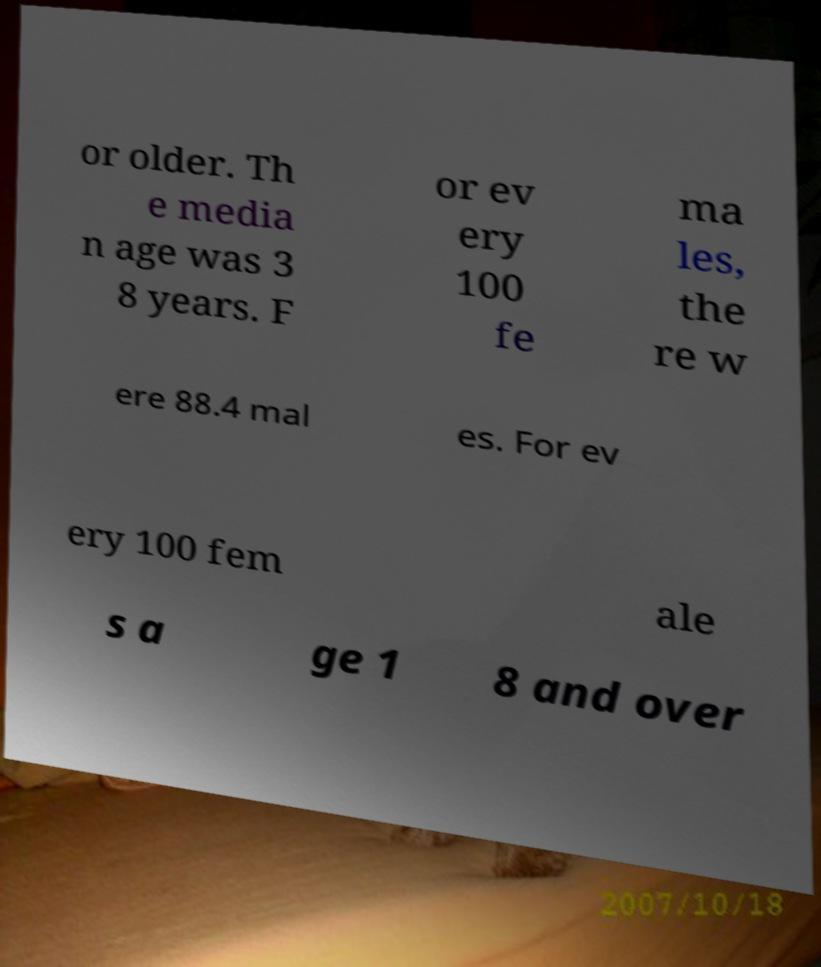Can you read and provide the text displayed in the image?This photo seems to have some interesting text. Can you extract and type it out for me? or older. Th e media n age was 3 8 years. F or ev ery 100 fe ma les, the re w ere 88.4 mal es. For ev ery 100 fem ale s a ge 1 8 and over 